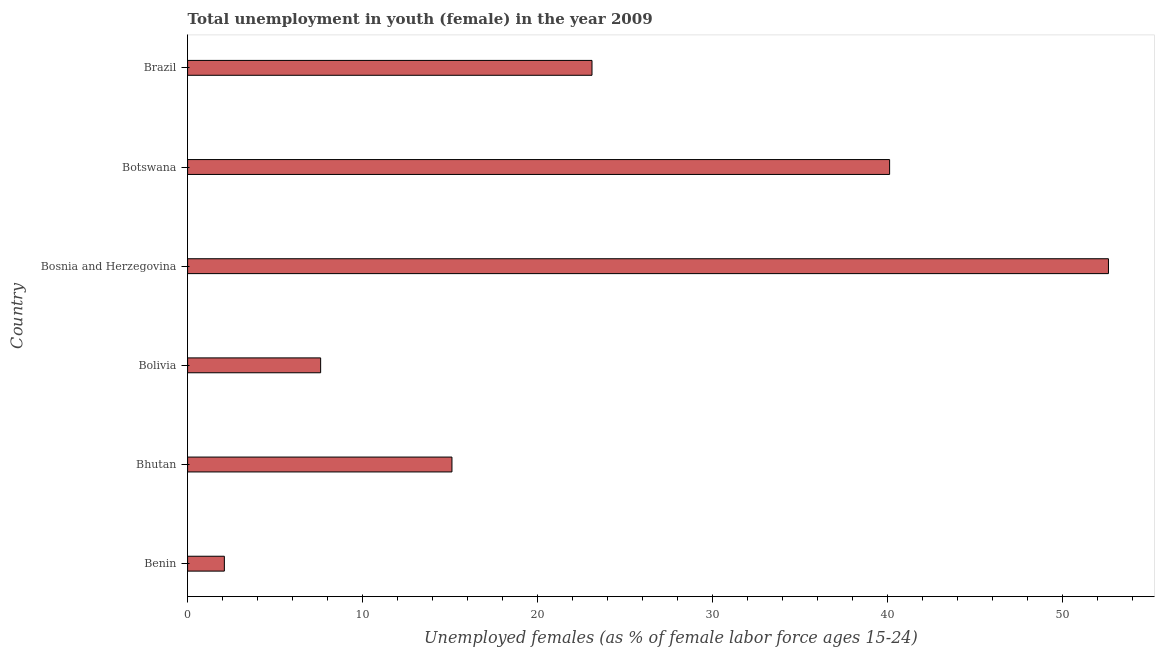What is the title of the graph?
Your response must be concise. Total unemployment in youth (female) in the year 2009. What is the label or title of the X-axis?
Provide a short and direct response. Unemployed females (as % of female labor force ages 15-24). What is the label or title of the Y-axis?
Offer a terse response. Country. What is the unemployed female youth population in Botswana?
Your answer should be very brief. 40.1. Across all countries, what is the maximum unemployed female youth population?
Make the answer very short. 52.6. Across all countries, what is the minimum unemployed female youth population?
Provide a short and direct response. 2.1. In which country was the unemployed female youth population maximum?
Give a very brief answer. Bosnia and Herzegovina. In which country was the unemployed female youth population minimum?
Ensure brevity in your answer.  Benin. What is the sum of the unemployed female youth population?
Give a very brief answer. 140.6. What is the average unemployed female youth population per country?
Your answer should be very brief. 23.43. What is the median unemployed female youth population?
Make the answer very short. 19.1. What is the ratio of the unemployed female youth population in Benin to that in Bosnia and Herzegovina?
Give a very brief answer. 0.04. Is the difference between the unemployed female youth population in Bhutan and Bosnia and Herzegovina greater than the difference between any two countries?
Offer a terse response. No. What is the difference between the highest and the second highest unemployed female youth population?
Your answer should be very brief. 12.5. Is the sum of the unemployed female youth population in Bosnia and Herzegovina and Botswana greater than the maximum unemployed female youth population across all countries?
Your response must be concise. Yes. What is the difference between the highest and the lowest unemployed female youth population?
Provide a short and direct response. 50.5. How many bars are there?
Keep it short and to the point. 6. Are all the bars in the graph horizontal?
Provide a short and direct response. Yes. How many countries are there in the graph?
Offer a terse response. 6. What is the difference between two consecutive major ticks on the X-axis?
Provide a succinct answer. 10. Are the values on the major ticks of X-axis written in scientific E-notation?
Provide a short and direct response. No. What is the Unemployed females (as % of female labor force ages 15-24) in Benin?
Offer a very short reply. 2.1. What is the Unemployed females (as % of female labor force ages 15-24) in Bhutan?
Provide a succinct answer. 15.1. What is the Unemployed females (as % of female labor force ages 15-24) of Bolivia?
Make the answer very short. 7.6. What is the Unemployed females (as % of female labor force ages 15-24) of Bosnia and Herzegovina?
Your response must be concise. 52.6. What is the Unemployed females (as % of female labor force ages 15-24) in Botswana?
Your answer should be compact. 40.1. What is the Unemployed females (as % of female labor force ages 15-24) in Brazil?
Your response must be concise. 23.1. What is the difference between the Unemployed females (as % of female labor force ages 15-24) in Benin and Bhutan?
Provide a short and direct response. -13. What is the difference between the Unemployed females (as % of female labor force ages 15-24) in Benin and Bolivia?
Provide a short and direct response. -5.5. What is the difference between the Unemployed females (as % of female labor force ages 15-24) in Benin and Bosnia and Herzegovina?
Make the answer very short. -50.5. What is the difference between the Unemployed females (as % of female labor force ages 15-24) in Benin and Botswana?
Ensure brevity in your answer.  -38. What is the difference between the Unemployed females (as % of female labor force ages 15-24) in Benin and Brazil?
Keep it short and to the point. -21. What is the difference between the Unemployed females (as % of female labor force ages 15-24) in Bhutan and Bolivia?
Provide a succinct answer. 7.5. What is the difference between the Unemployed females (as % of female labor force ages 15-24) in Bhutan and Bosnia and Herzegovina?
Keep it short and to the point. -37.5. What is the difference between the Unemployed females (as % of female labor force ages 15-24) in Bhutan and Brazil?
Provide a short and direct response. -8. What is the difference between the Unemployed females (as % of female labor force ages 15-24) in Bolivia and Bosnia and Herzegovina?
Make the answer very short. -45. What is the difference between the Unemployed females (as % of female labor force ages 15-24) in Bolivia and Botswana?
Make the answer very short. -32.5. What is the difference between the Unemployed females (as % of female labor force ages 15-24) in Bolivia and Brazil?
Offer a terse response. -15.5. What is the difference between the Unemployed females (as % of female labor force ages 15-24) in Bosnia and Herzegovina and Botswana?
Keep it short and to the point. 12.5. What is the difference between the Unemployed females (as % of female labor force ages 15-24) in Bosnia and Herzegovina and Brazil?
Make the answer very short. 29.5. What is the ratio of the Unemployed females (as % of female labor force ages 15-24) in Benin to that in Bhutan?
Offer a terse response. 0.14. What is the ratio of the Unemployed females (as % of female labor force ages 15-24) in Benin to that in Bolivia?
Your answer should be very brief. 0.28. What is the ratio of the Unemployed females (as % of female labor force ages 15-24) in Benin to that in Bosnia and Herzegovina?
Offer a terse response. 0.04. What is the ratio of the Unemployed females (as % of female labor force ages 15-24) in Benin to that in Botswana?
Your answer should be very brief. 0.05. What is the ratio of the Unemployed females (as % of female labor force ages 15-24) in Benin to that in Brazil?
Make the answer very short. 0.09. What is the ratio of the Unemployed females (as % of female labor force ages 15-24) in Bhutan to that in Bolivia?
Offer a terse response. 1.99. What is the ratio of the Unemployed females (as % of female labor force ages 15-24) in Bhutan to that in Bosnia and Herzegovina?
Provide a succinct answer. 0.29. What is the ratio of the Unemployed females (as % of female labor force ages 15-24) in Bhutan to that in Botswana?
Your response must be concise. 0.38. What is the ratio of the Unemployed females (as % of female labor force ages 15-24) in Bhutan to that in Brazil?
Provide a succinct answer. 0.65. What is the ratio of the Unemployed females (as % of female labor force ages 15-24) in Bolivia to that in Bosnia and Herzegovina?
Provide a short and direct response. 0.14. What is the ratio of the Unemployed females (as % of female labor force ages 15-24) in Bolivia to that in Botswana?
Give a very brief answer. 0.19. What is the ratio of the Unemployed females (as % of female labor force ages 15-24) in Bolivia to that in Brazil?
Give a very brief answer. 0.33. What is the ratio of the Unemployed females (as % of female labor force ages 15-24) in Bosnia and Herzegovina to that in Botswana?
Give a very brief answer. 1.31. What is the ratio of the Unemployed females (as % of female labor force ages 15-24) in Bosnia and Herzegovina to that in Brazil?
Provide a succinct answer. 2.28. What is the ratio of the Unemployed females (as % of female labor force ages 15-24) in Botswana to that in Brazil?
Keep it short and to the point. 1.74. 